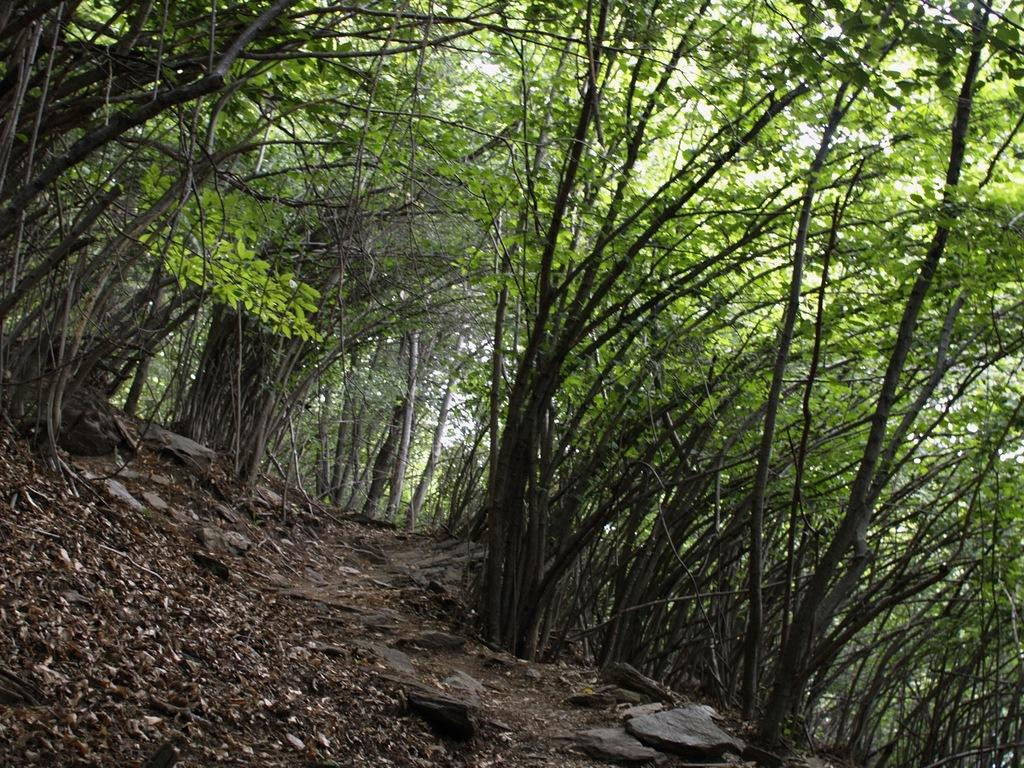What can be seen at the bottom of the image? The ground is visible at the bottom of the image. What is on the ground in the image? Dry leaves and stones are present on the ground. What is visible in the background of the image? There are trees in the background of the image. What type of theory can be seen being discussed by the owl in the image? There is no owl present in the image, and therefore no theory can be seen being discussed. 